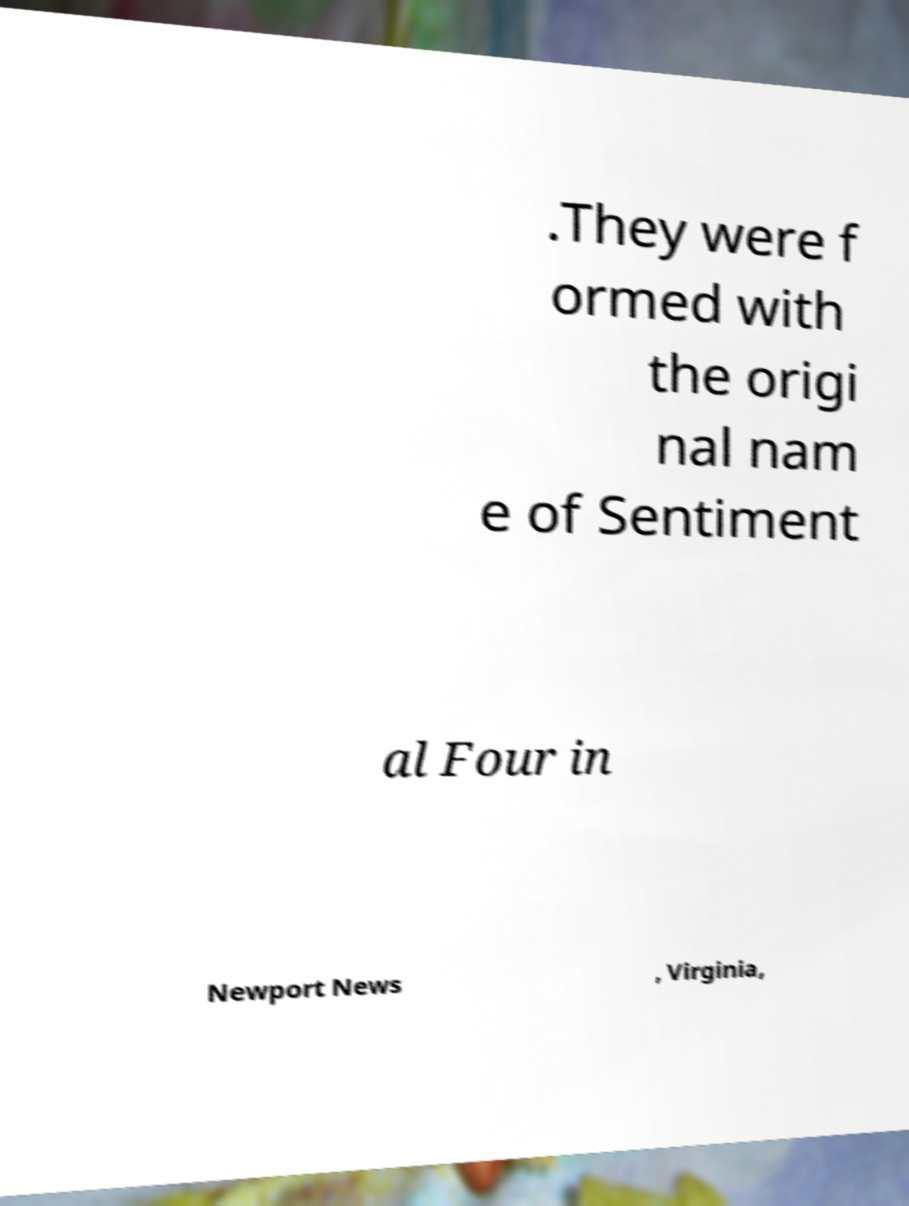What messages or text are displayed in this image? I need them in a readable, typed format. .They were f ormed with the origi nal nam e of Sentiment al Four in Newport News , Virginia, 